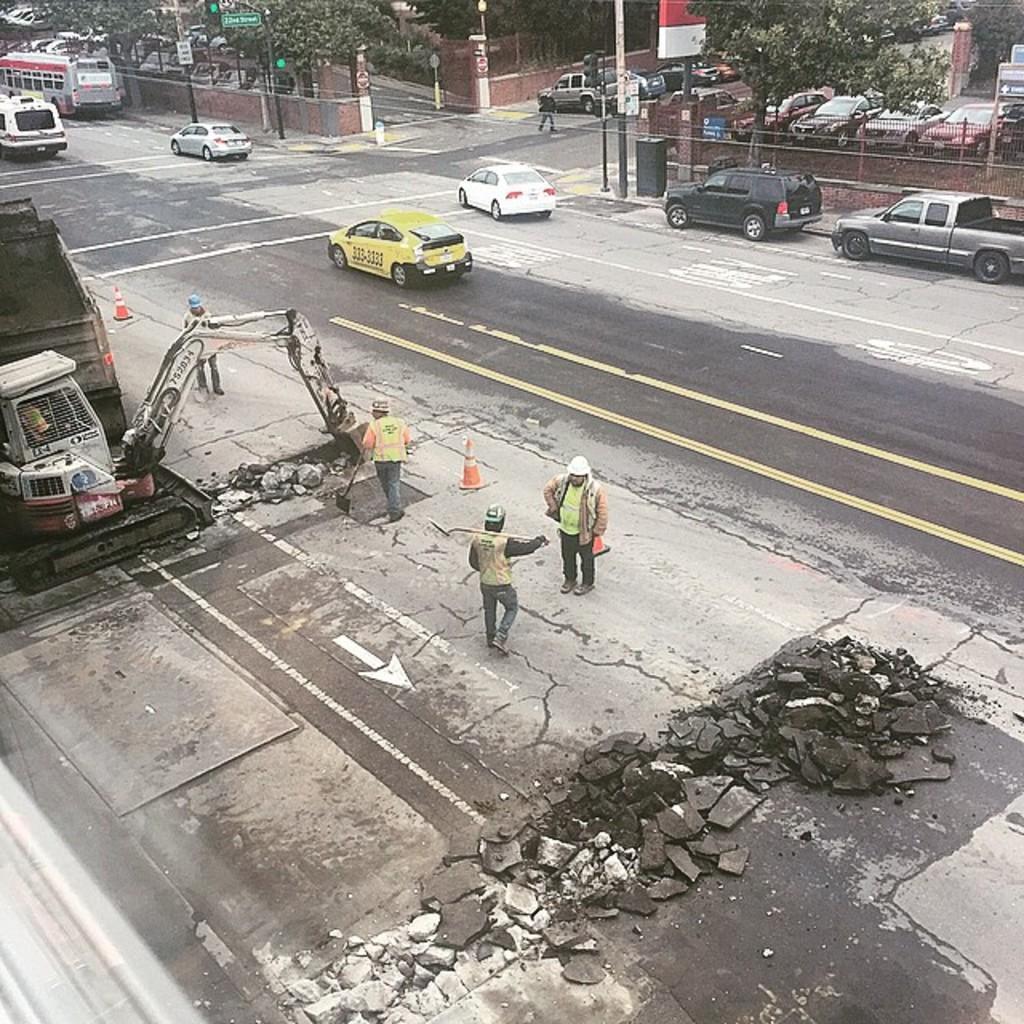Describe this image in one or two sentences. In this image, we can see some vehicles and trees. There is a wall at the top of the image. There is a truck and excavator on the left side of the image. There are three persons in the middle of the image wearing clothes. 